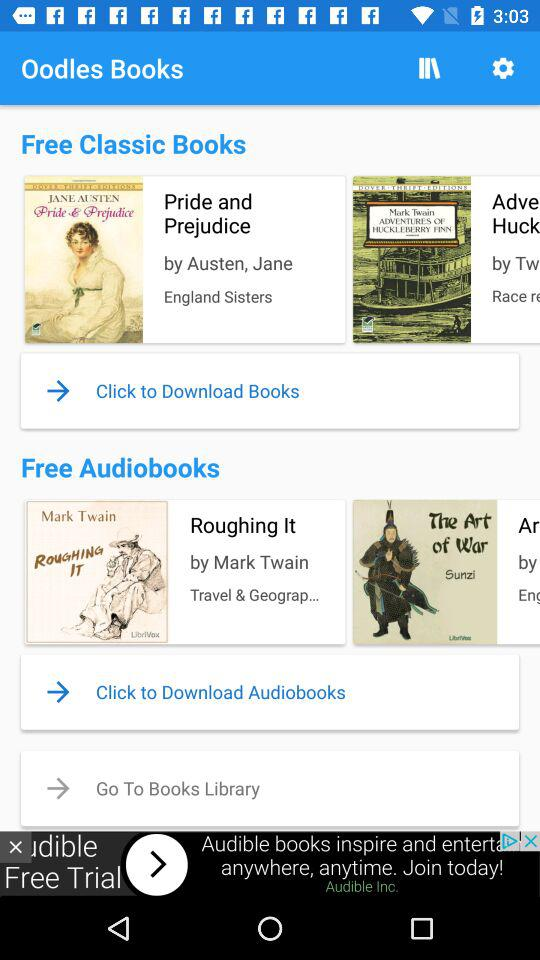What are the free audiobooks? The free audiobook is "Roughing It". 